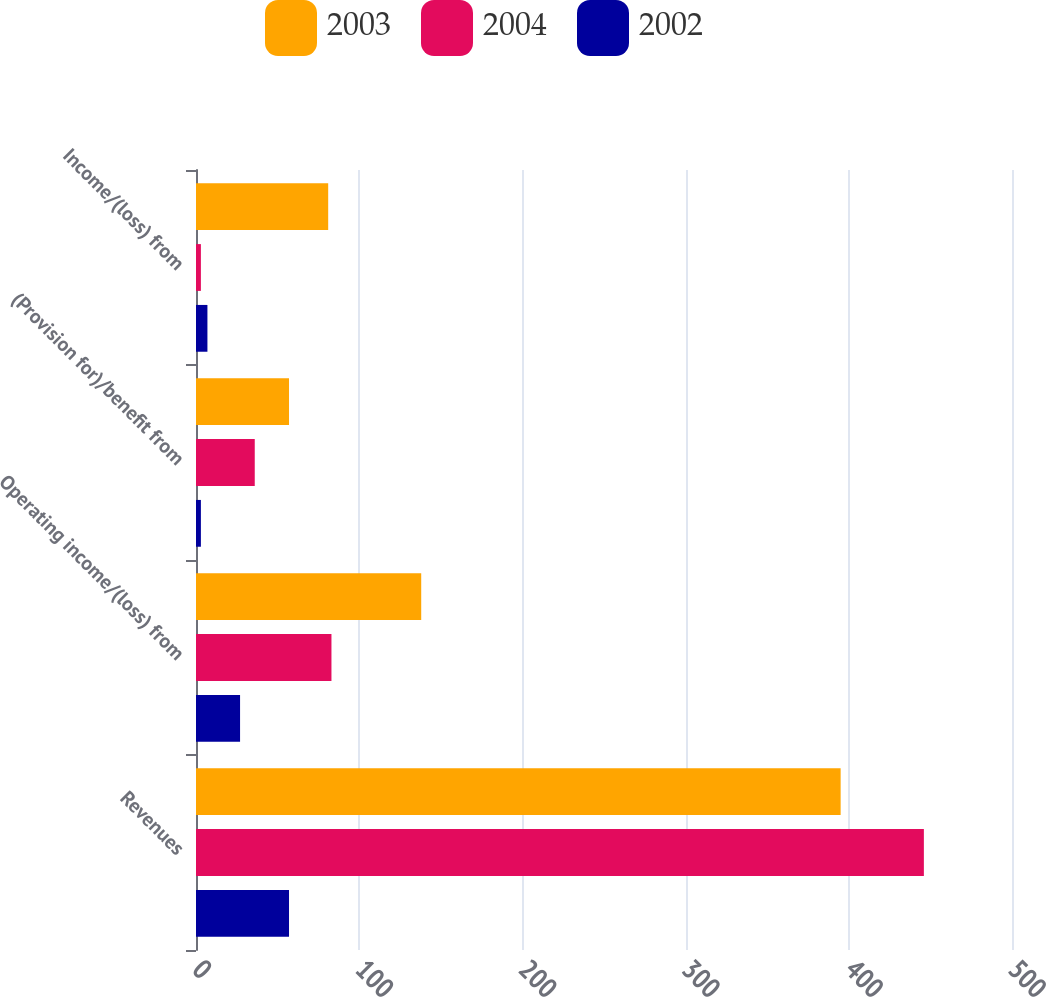Convert chart to OTSL. <chart><loc_0><loc_0><loc_500><loc_500><stacked_bar_chart><ecel><fcel>Revenues<fcel>Operating income/(loss) from<fcel>(Provision for)/benefit from<fcel>Income/(loss) from<nl><fcel>2003<fcel>395<fcel>138<fcel>57<fcel>81<nl><fcel>2004<fcel>446<fcel>83<fcel>36<fcel>3<nl><fcel>2002<fcel>57<fcel>27<fcel>3<fcel>7<nl></chart> 